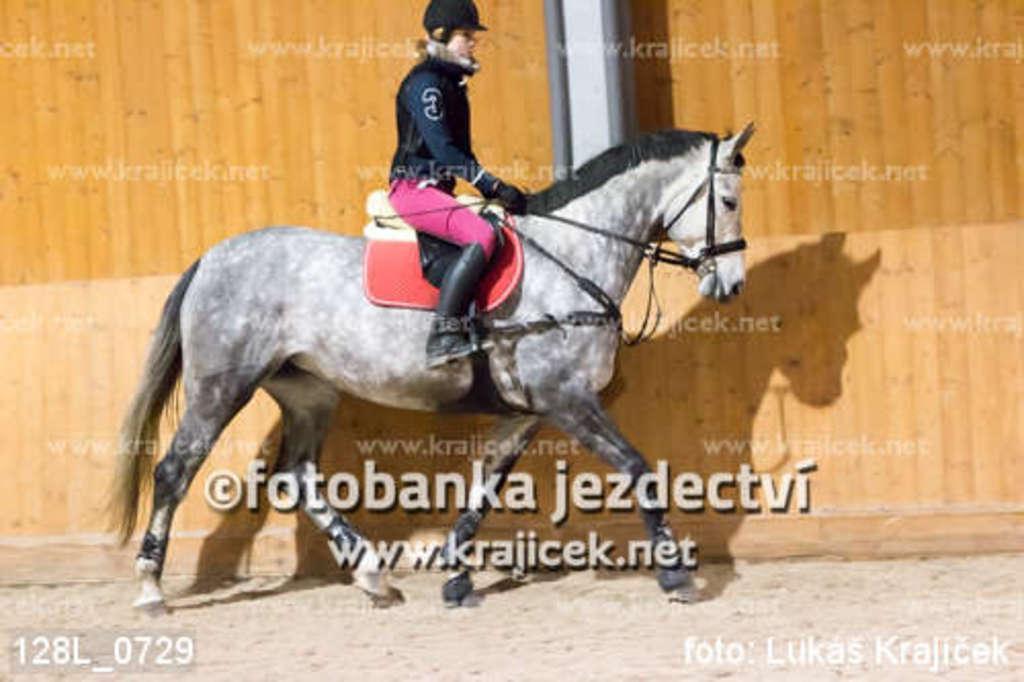Describe this image in one or two sentences. In the foreground I can see a person is riding a horse on the ground, text and sand. In the background I can see a wall and pillar. This image is taken may be during a day. 